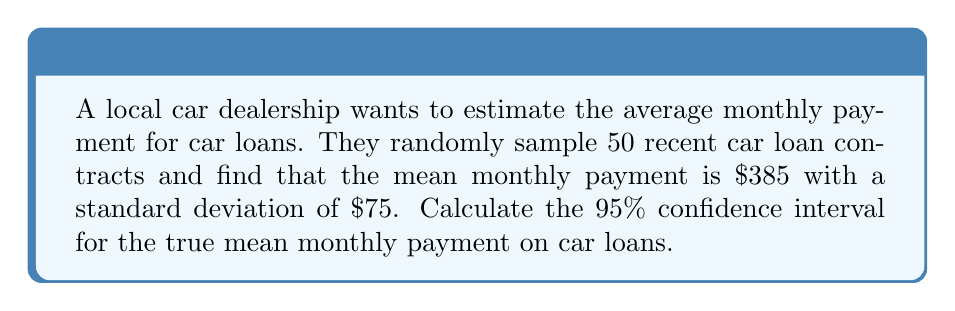Can you solve this math problem? Let's approach this step-by-step:

1) We're given:
   - Sample size (n) = 50
   - Sample mean ($\bar{x}$) = $385
   - Sample standard deviation (s) = $75
   - Confidence level = 95%

2) For a 95% confidence interval, we use a z-score of 1.96.

3) The formula for the confidence interval is:

   $$\bar{x} \pm z \cdot \frac{s}{\sqrt{n}}$$

4) Let's calculate the standard error:

   $$\frac{s}{\sqrt{n}} = \frac{75}{\sqrt{50}} = \frac{75}{7.07} = 10.61$$

5) Now, let's multiply this by our z-score:

   $$1.96 \cdot 10.61 = 20.80$$

6) Finally, we can calculate our confidence interval:

   Lower bound: $385 - 20.80 = 364.20$
   Upper bound: $385 + 20.80 = 405.80$

7) Therefore, we can say with 95% confidence that the true mean monthly payment on car loans is between $364.20 and $405.80.
Answer: ($364.20, $405.80) 